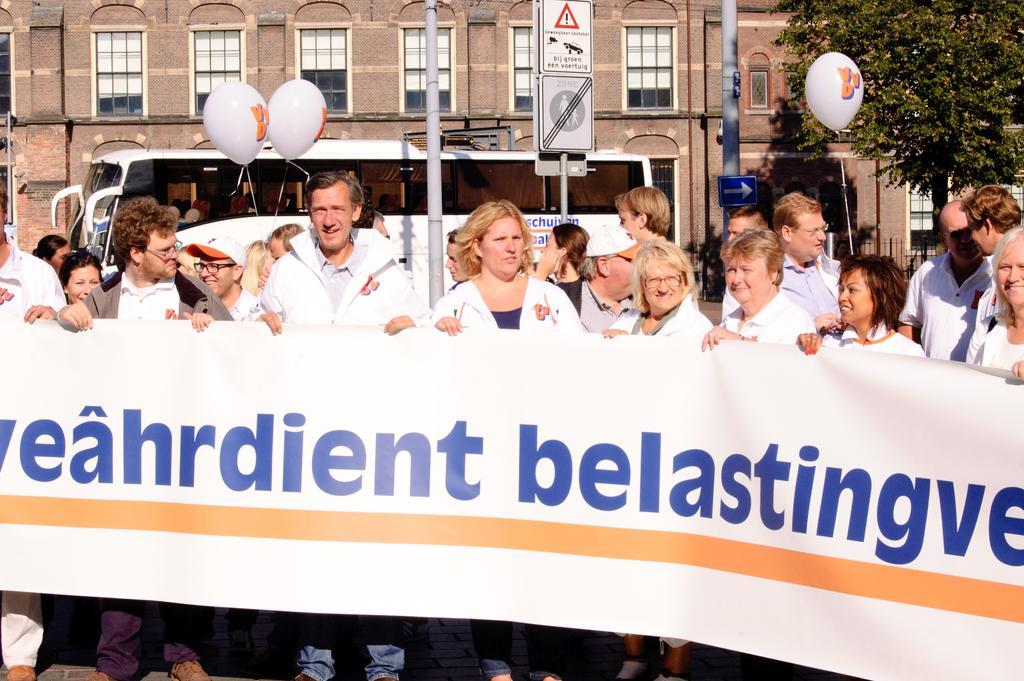How would you summarize this image in a sentence or two? In this image I can see the group of people standing and these people are wearing the white color shirts and holding the banner. On the banner I can see something is written. In the background I can see the balloons, vehicle, boards to the poles. I can also building with windows and many trees. 